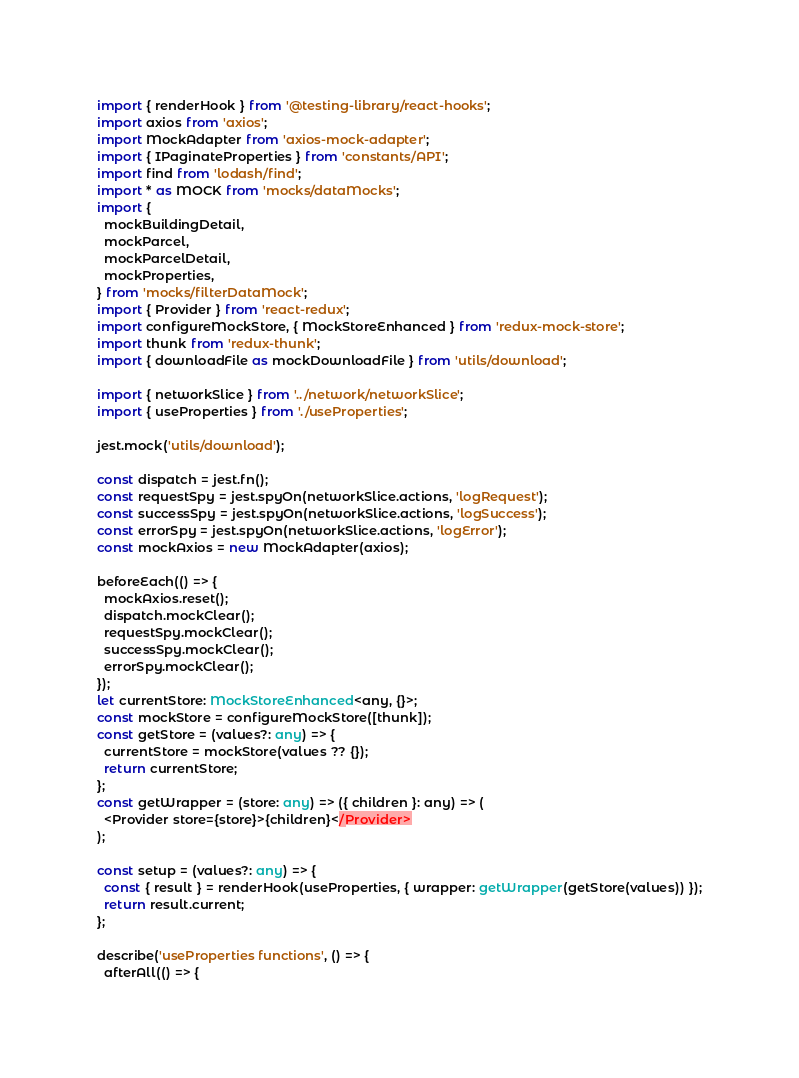Convert code to text. <code><loc_0><loc_0><loc_500><loc_500><_TypeScript_>import { renderHook } from '@testing-library/react-hooks';
import axios from 'axios';
import MockAdapter from 'axios-mock-adapter';
import { IPaginateProperties } from 'constants/API';
import find from 'lodash/find';
import * as MOCK from 'mocks/dataMocks';
import {
  mockBuildingDetail,
  mockParcel,
  mockParcelDetail,
  mockProperties,
} from 'mocks/filterDataMock';
import { Provider } from 'react-redux';
import configureMockStore, { MockStoreEnhanced } from 'redux-mock-store';
import thunk from 'redux-thunk';
import { downloadFile as mockDownloadFile } from 'utils/download';

import { networkSlice } from '../network/networkSlice';
import { useProperties } from './useProperties';

jest.mock('utils/download');

const dispatch = jest.fn();
const requestSpy = jest.spyOn(networkSlice.actions, 'logRequest');
const successSpy = jest.spyOn(networkSlice.actions, 'logSuccess');
const errorSpy = jest.spyOn(networkSlice.actions, 'logError');
const mockAxios = new MockAdapter(axios);

beforeEach(() => {
  mockAxios.reset();
  dispatch.mockClear();
  requestSpy.mockClear();
  successSpy.mockClear();
  errorSpy.mockClear();
});
let currentStore: MockStoreEnhanced<any, {}>;
const mockStore = configureMockStore([thunk]);
const getStore = (values?: any) => {
  currentStore = mockStore(values ?? {});
  return currentStore;
};
const getWrapper = (store: any) => ({ children }: any) => (
  <Provider store={store}>{children}</Provider>
);

const setup = (values?: any) => {
  const { result } = renderHook(useProperties, { wrapper: getWrapper(getStore(values)) });
  return result.current;
};

describe('useProperties functions', () => {
  afterAll(() => {</code> 